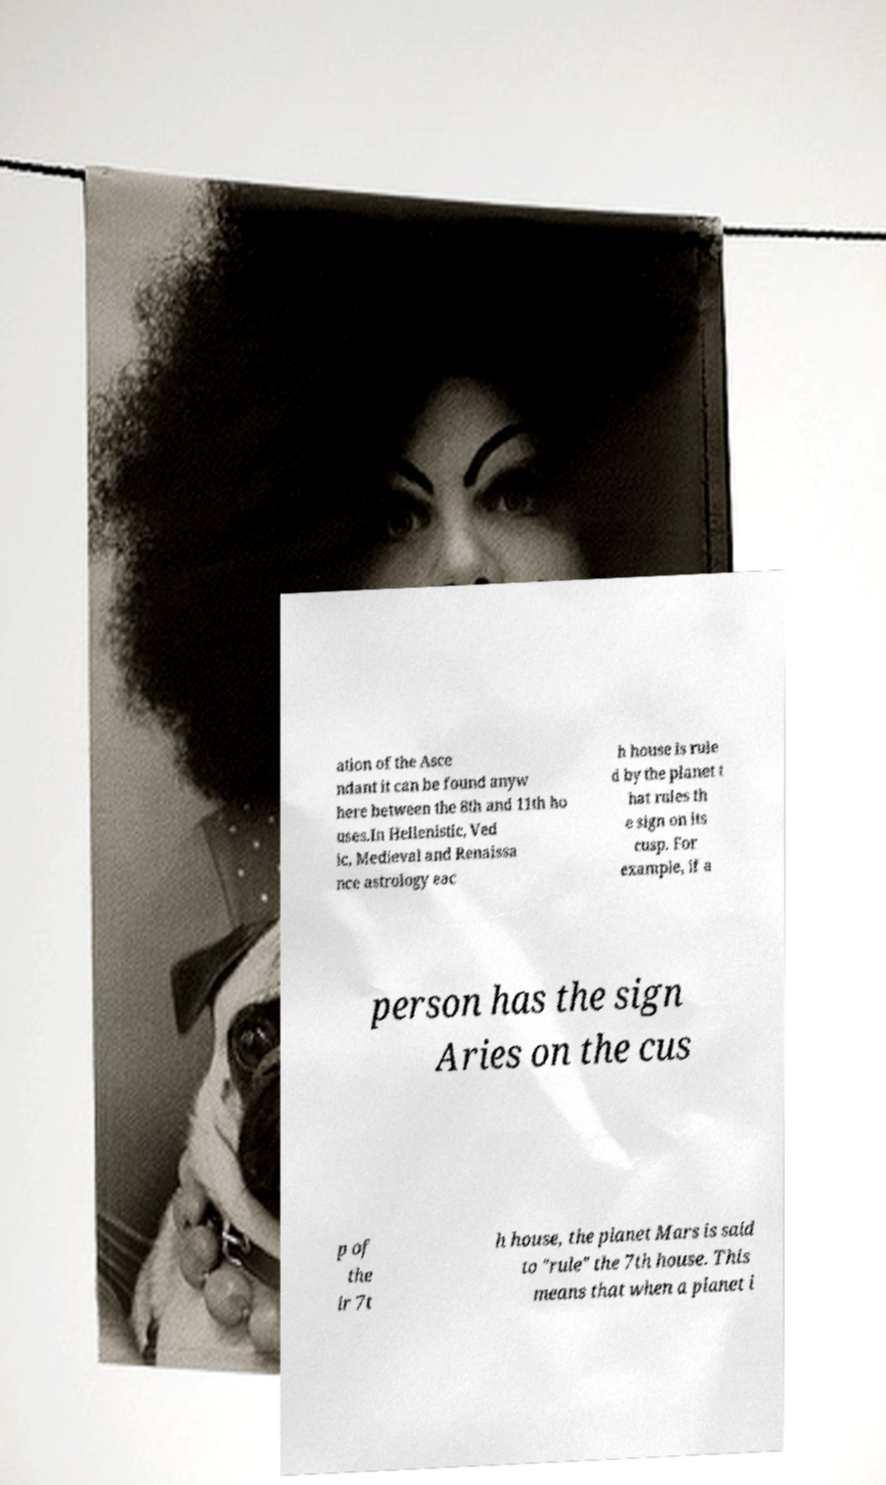Please read and relay the text visible in this image. What does it say? ation of the Asce ndant it can be found anyw here between the 8th and 11th ho uses.In Hellenistic, Ved ic, Medieval and Renaissa nce astrology eac h house is rule d by the planet t hat rules th e sign on its cusp. For example, if a person has the sign Aries on the cus p of the ir 7t h house, the planet Mars is said to "rule" the 7th house. This means that when a planet i 